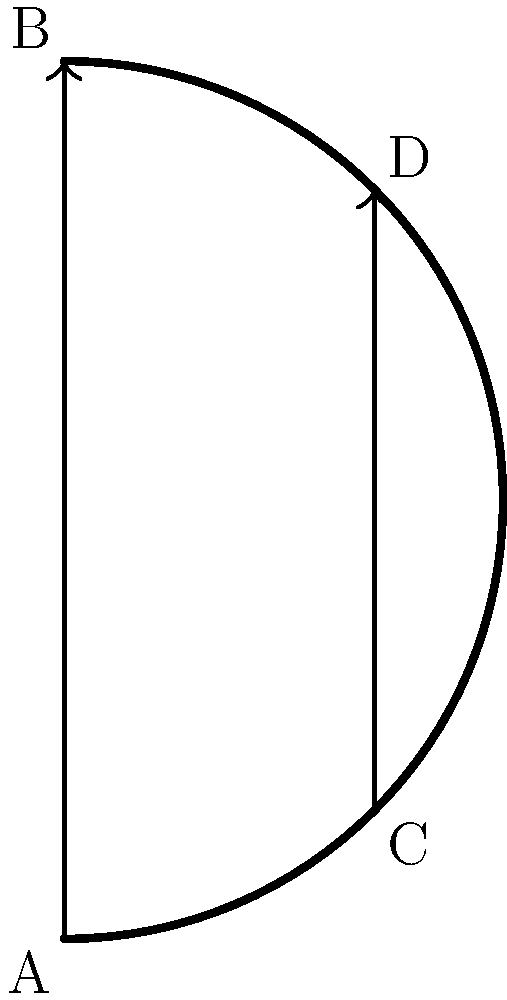In a crucial game against the rival Washington Huskies, the Oregon Ducks are experimenting with non-Euclidean passing strategies on a curved court surface. Two players attempt parallel passes along the curved surface shown. If the passes start at points A and C and end at points B and D respectively, how do these "parallel" passing lanes behave differently compared to traditional flat-court passes? To understand how parallel passing lanes behave on a curved surface, let's break it down step-by-step:

1. In Euclidean geometry (flat surface), parallel lines maintain a constant distance from each other and never intersect.

2. On a curved surface, we're dealing with non-Euclidean geometry, specifically spherical geometry in this case.

3. The passing lanes (AB and CD) appear to be parallel at their starting points A and C.

4. As the passes travel along the curved surface:
   a) The distance between the passing lanes decreases as they approach the top of the curve.
   b) If extended beyond the shown arc, these "parallel" lines would eventually intersect.

5. This behavior is analogous to lines of longitude on a globe:
   a) They appear parallel at the equator.
   b) They converge and meet at the poles.

6. In spherical geometry, the sum of the angles in a triangle is greater than 180°, unlike in Euclidean geometry where it's exactly 180°.

7. The curvature of the surface affects the path of the "straight" passes, making them follow geodesics (shortest paths between two points on a curved surface).

8. As a result, passes that start parallel on this curved court will appear to bend towards each other, potentially intersecting if the surface were extended.

This non-Euclidean behavior could create unique passing opportunities and challenges for the Oregon Ducks, requiring players to adjust their spatial awareness and passing strategies accordingly.
Answer: The "parallel" passing lanes converge as they progress along the curved surface, unlike traditional flat-court passes which remain equidistant. 